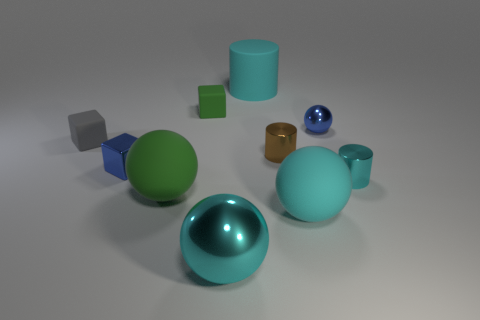Subtract all cylinders. How many objects are left? 7 Subtract all red matte cylinders. Subtract all small blue shiny cubes. How many objects are left? 9 Add 3 tiny cylinders. How many tiny cylinders are left? 5 Add 1 green matte things. How many green matte things exist? 3 Subtract 0 gray cylinders. How many objects are left? 10 